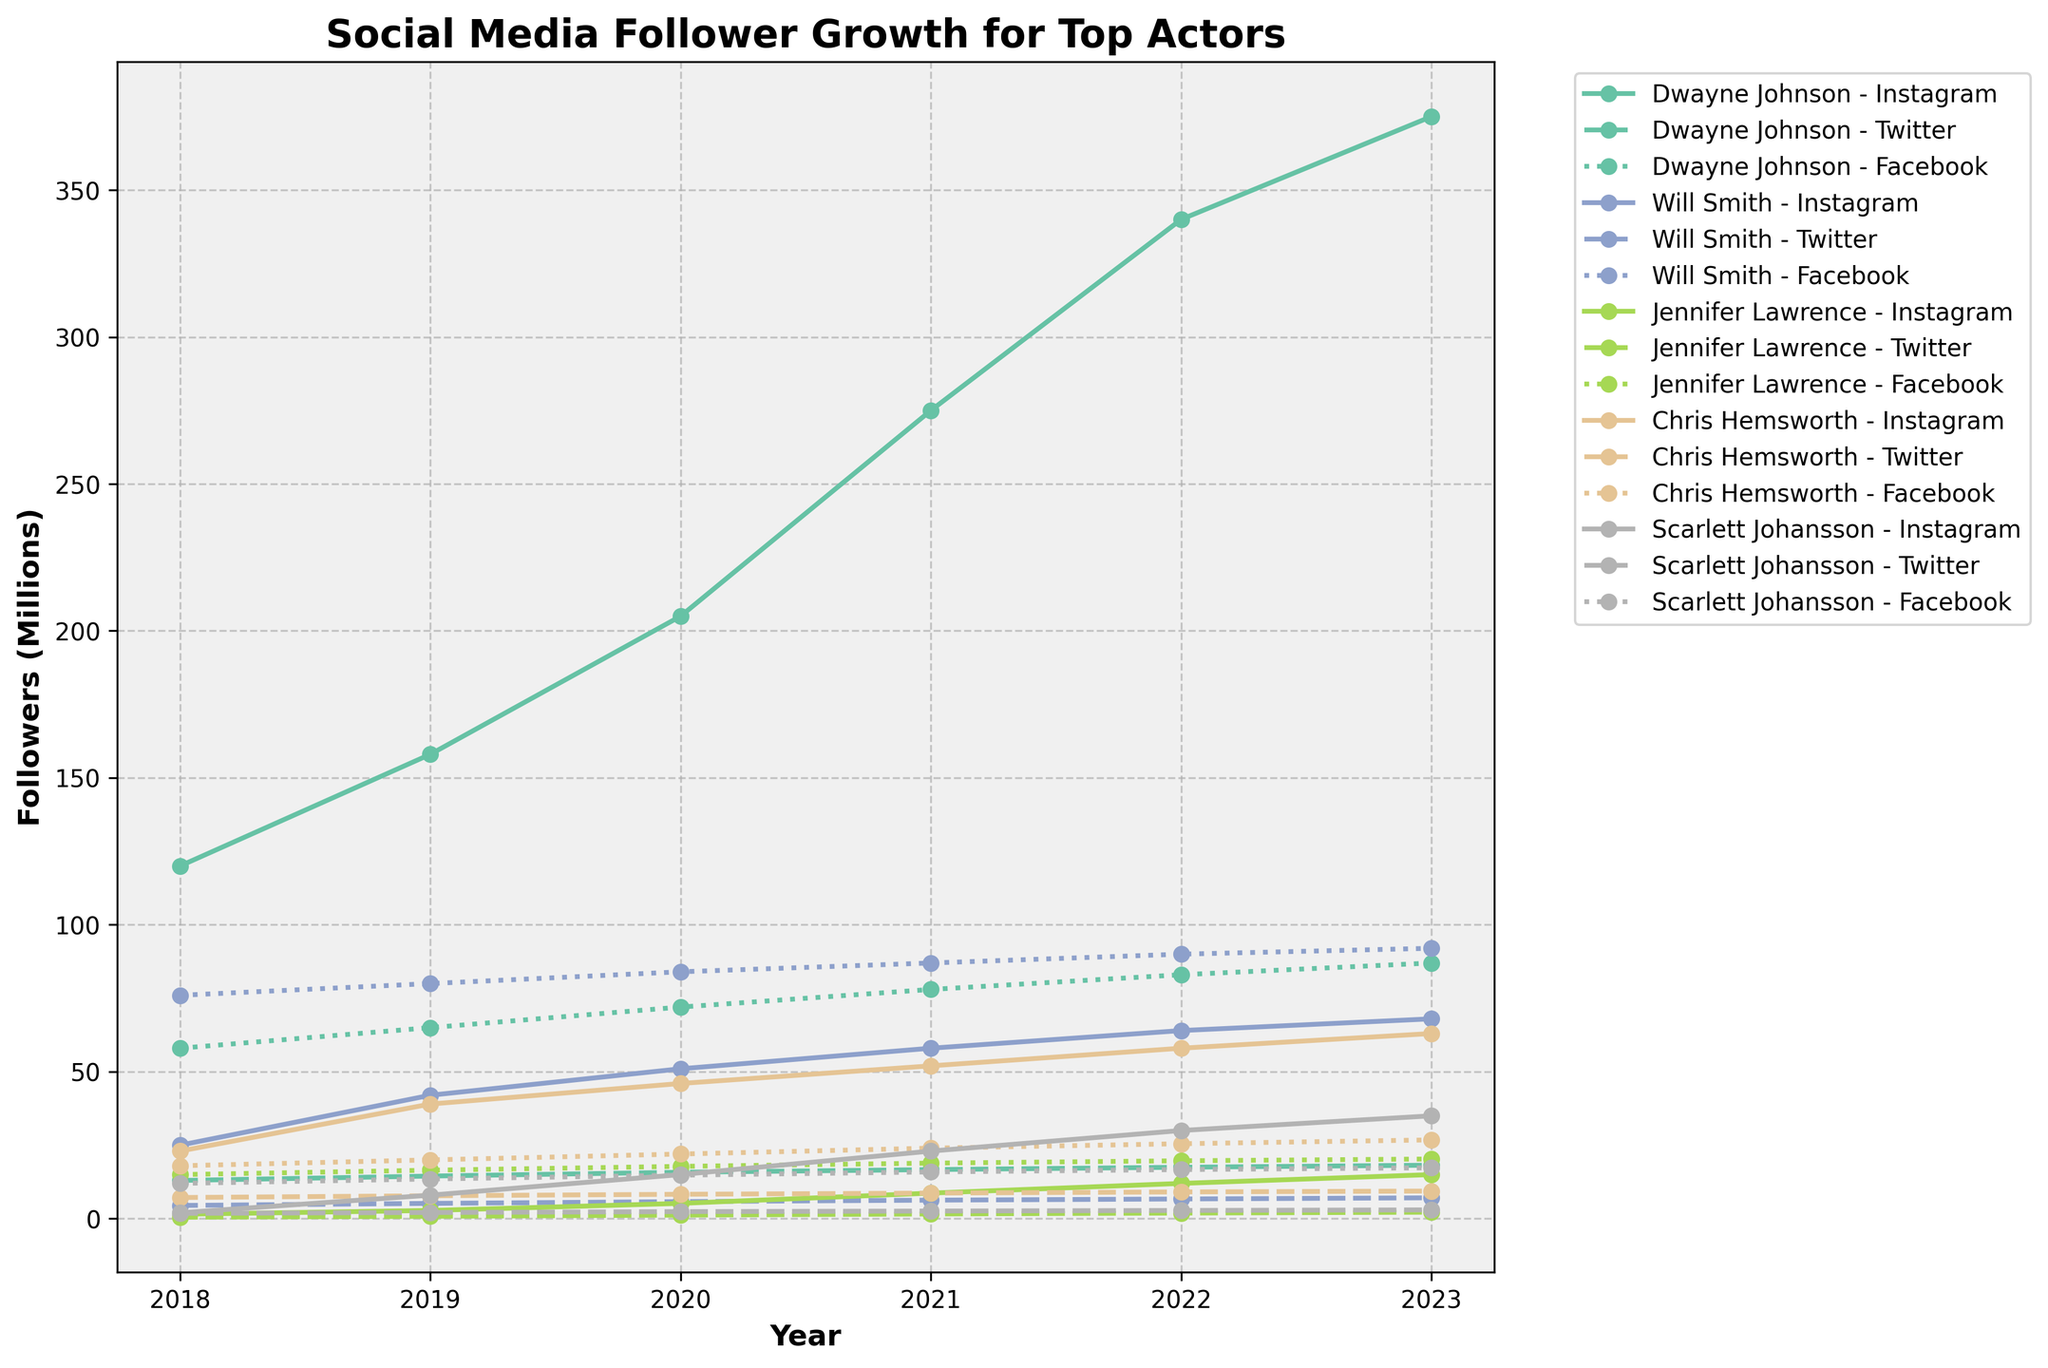What's the general trend for Dwayne Johnson's Instagram followers from 2018 to 2023? Dwayne Johnson's Instagram followers consistently increased each year from 120 million in 2018 to 375 million in 2023.
Answer: Consistently increasing Whose Facebook following grew the most from 2018 to 2023? Subtract the 2018 value from the 2023 value for each actor's Facebook followers. Dwayne Johnson: 87 - 58 = 29M, Will Smith: 92 - 76 = 16M, Jennifer Lawrence: 20.3 - 15 = 5.3M, Chris Hemsworth: 26.8 - 18 = 8.8M, Scarlett Johansson: 17.3 - 12 = 5.3M. Dwayne Johnson's Facebook following grew the most.
Answer: Dwayne Johnson How do the Instagram follower counts for Jennifer Lawrence and Scarlett Johansson compare in 2023? In 2023, Jennifer Lawrence has 15M followers, while Scarlett Johansson has 35M followers. Scarlett Johansson has significantly more followers than Jennifer Lawrence.
Answer: Scarlett Johansson has more What’s the difference in the number of Instagram followers between Will Smith and Chris Hemsworth in 2023? Subtract Chris Hemsworth's followers from Will Smith's in 2023: 68 - 63 = 5M followers.
Answer: 5 million Between 2019 and 2020, which actor had the largest increase in Instagram followers? Calculate the difference for each actor: Dwayne Johnson: 205 - 158 = 47M, Will Smith: 51 - 42 = 9M, Jennifer Lawrence: 5.2 - 2.8 = 2.4M, Chris Hemsworth: 46 - 39 = 7M, Scarlett Johansson: 15 - 8 = 7M. Dwayne Johnson had the largest increase.
Answer: Dwayne Johnson Among Twitter followers, which actor shows the smallest overall growth from 2018 to 2023? Calculate growth for each actor: Dwayne Johnson: 18.2 - 13 = 5.2M, Will Smith: 7.1 - 4.5 = 2.6M, Jennifer Lawrence: 2.2 - 0.5 = 1.7M, Chris Hemsworth: 9.4 - 7.2 = 2.2M, Scarlett Johansson: 3 - 1.8 = 1.2M. Scarlett Johansson shows the smallest growth.
Answer: Scarlett Johansson How do the growth rates compare between Facebook and Instagram for Dwayne Johnson from 2018 to 2023? Calculate growth rates: Facebook: (87-58)/58 = 0.5 or 50%, Instagram: (375-120)/120 = 2.125 or 212.5%. Instagram growth rate is much higher than Facebook's for Dwayne Johnson.
Answer: Instagram's growth rate is higher What is the average number of Instagram followers for Scarlett Johansson over the entire period? Sum the followers from each year and divide by the number of years: (2+8+15+23+30+35)/6 = 113/6 = ~18.83M.
Answer: ~18.83 million For which year did Will Smith see his largest single-year gain in Instagram followers? Calculate single-year gains: 2019-2018: 42-25=17M, 2020-2019: 51-42=9M, 2021-2020: 58-51=7M, 2022-2021: 64-58=6M, 2023-2022: 68-64=4M. The largest gain is from 2018 to 2019.
Answer: 2019 Who had more Twitter followers in 2023, Dwayne Johnson or Chris Hemsworth? In 2023, Dwayne Johnson had 18.2M Twitter followers, while Chris Hemsworth had 9.4M. Dwayne Johnson had more followers.
Answer: Dwayne Johnson 